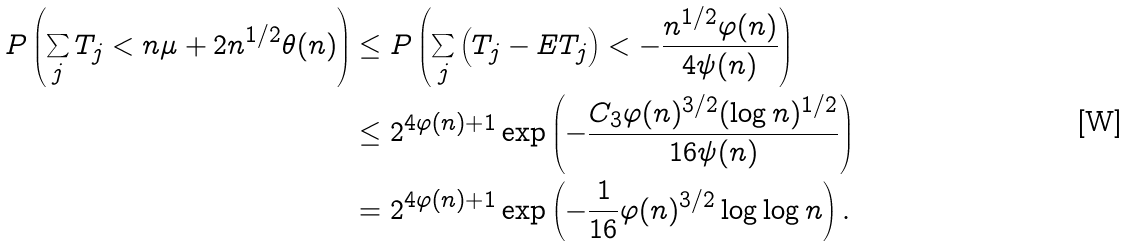Convert formula to latex. <formula><loc_0><loc_0><loc_500><loc_500>P \left ( \sum _ { j } T _ { j } < n \mu + 2 n ^ { 1 / 2 } \theta ( n ) \right ) & \leq P \left ( \sum _ { j } \left ( T _ { j } - E T _ { j } \right ) < - \frac { n ^ { 1 / 2 } \varphi ( n ) } { 4 \psi ( n ) } \right ) \\ & \leq 2 ^ { 4 \varphi ( n ) + 1 } \exp \left ( - \frac { C _ { 3 } \varphi ( n ) ^ { 3 / 2 } ( \log n ) ^ { 1 / 2 } } { 1 6 \psi ( n ) } \right ) \\ & = 2 ^ { 4 \varphi ( n ) + 1 } \exp \left ( - \frac { 1 } { 1 6 } \varphi ( n ) ^ { 3 / 2 } \log \log n \right ) .</formula> 